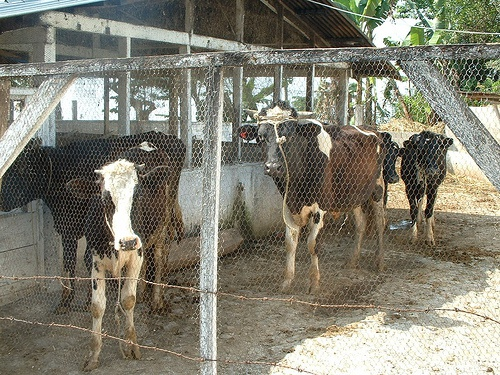Describe the objects in this image and their specific colors. I can see cow in white, gray, black, and maroon tones, cow in white, gray, black, and ivory tones, cow in white, black, and gray tones, cow in white, black, and gray tones, and cow in white, black, and gray tones in this image. 